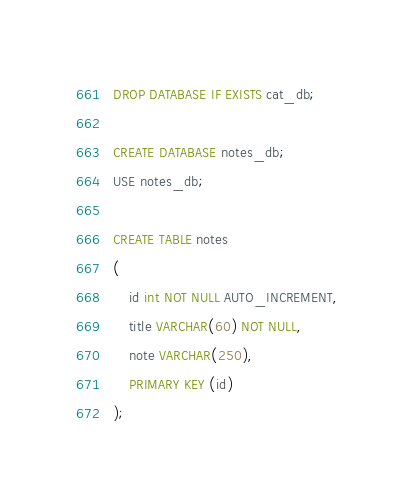<code> <loc_0><loc_0><loc_500><loc_500><_SQL_>DROP DATABASE IF EXISTS cat_db;

CREATE DATABASE notes_db;
USE notes_db;

CREATE TABLE notes
(
	id int NOT NULL AUTO_INCREMENT,
	title VARCHAR(60) NOT NULL,
	note VARCHAR(250),
	PRIMARY KEY (id)
);
</code> 